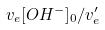Convert formula to latex. <formula><loc_0><loc_0><loc_500><loc_500>v _ { e } [ O H ^ { - } ] _ { 0 } / v _ { e } ^ { \prime }</formula> 